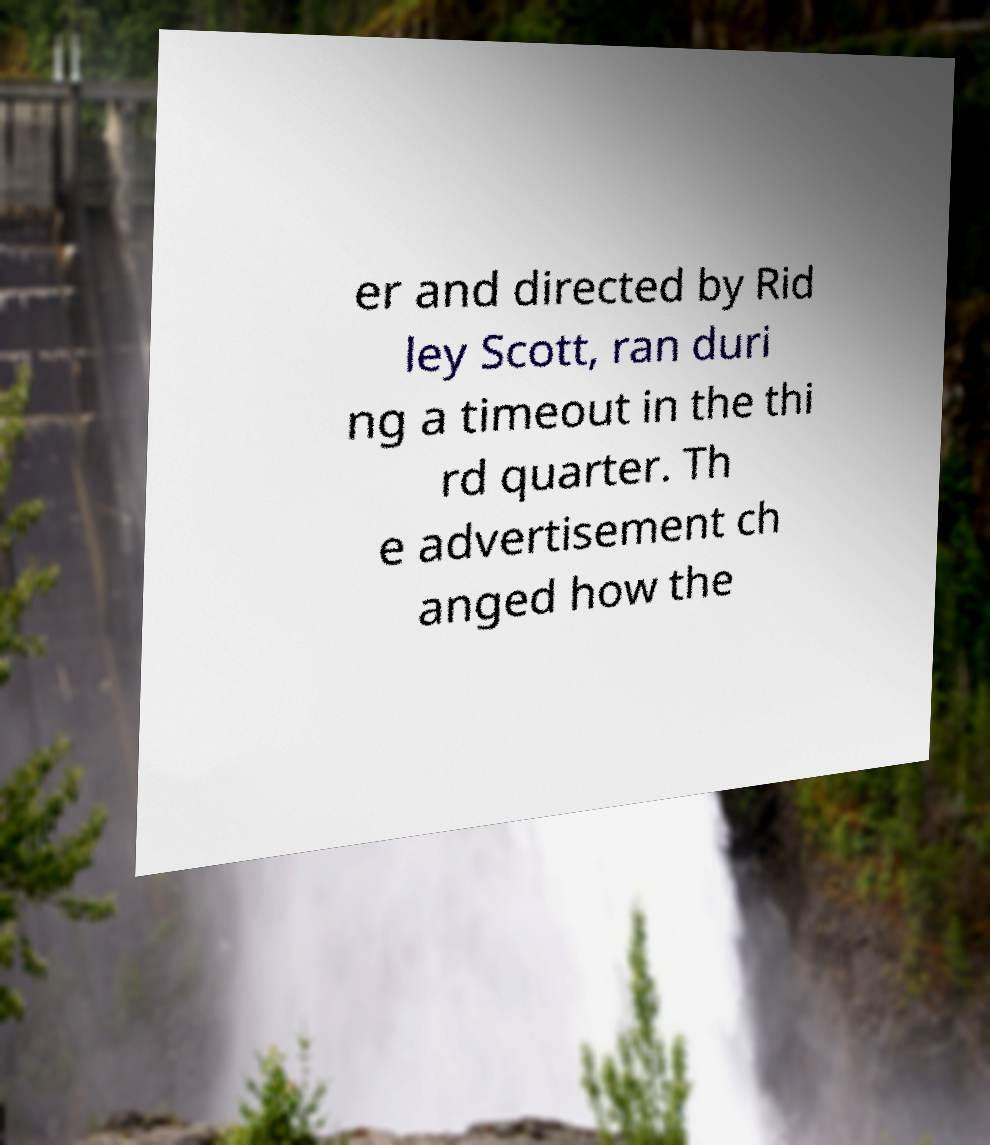Could you extract and type out the text from this image? er and directed by Rid ley Scott, ran duri ng a timeout in the thi rd quarter. Th e advertisement ch anged how the 